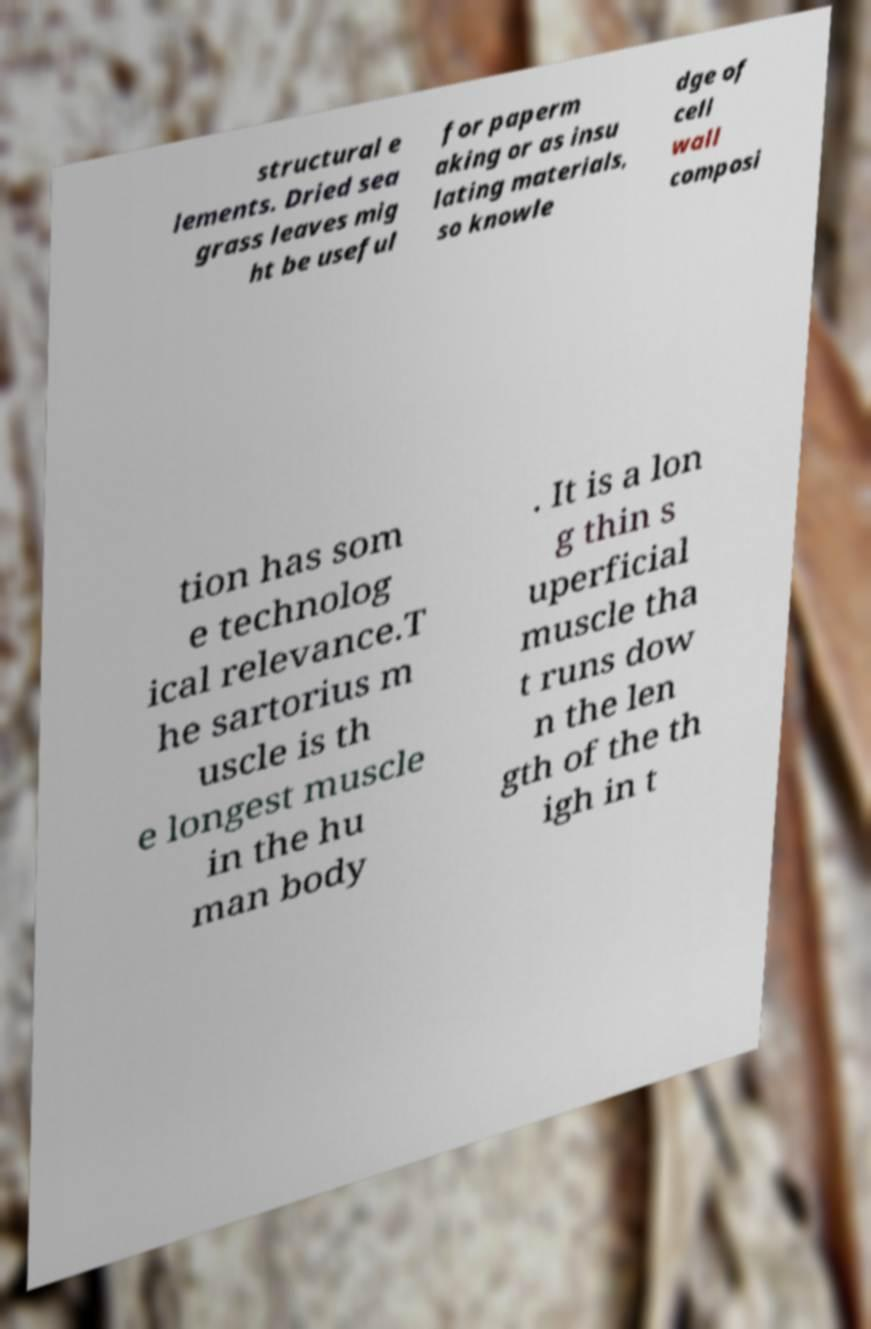What messages or text are displayed in this image? I need them in a readable, typed format. structural e lements. Dried sea grass leaves mig ht be useful for paperm aking or as insu lating materials, so knowle dge of cell wall composi tion has som e technolog ical relevance.T he sartorius m uscle is th e longest muscle in the hu man body . It is a lon g thin s uperficial muscle tha t runs dow n the len gth of the th igh in t 